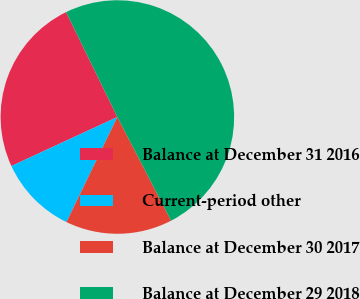Convert chart. <chart><loc_0><loc_0><loc_500><loc_500><pie_chart><fcel>Balance at December 31 2016<fcel>Current-period other<fcel>Balance at December 30 2017<fcel>Balance at December 29 2018<nl><fcel>24.66%<fcel>10.92%<fcel>14.79%<fcel>49.63%<nl></chart> 